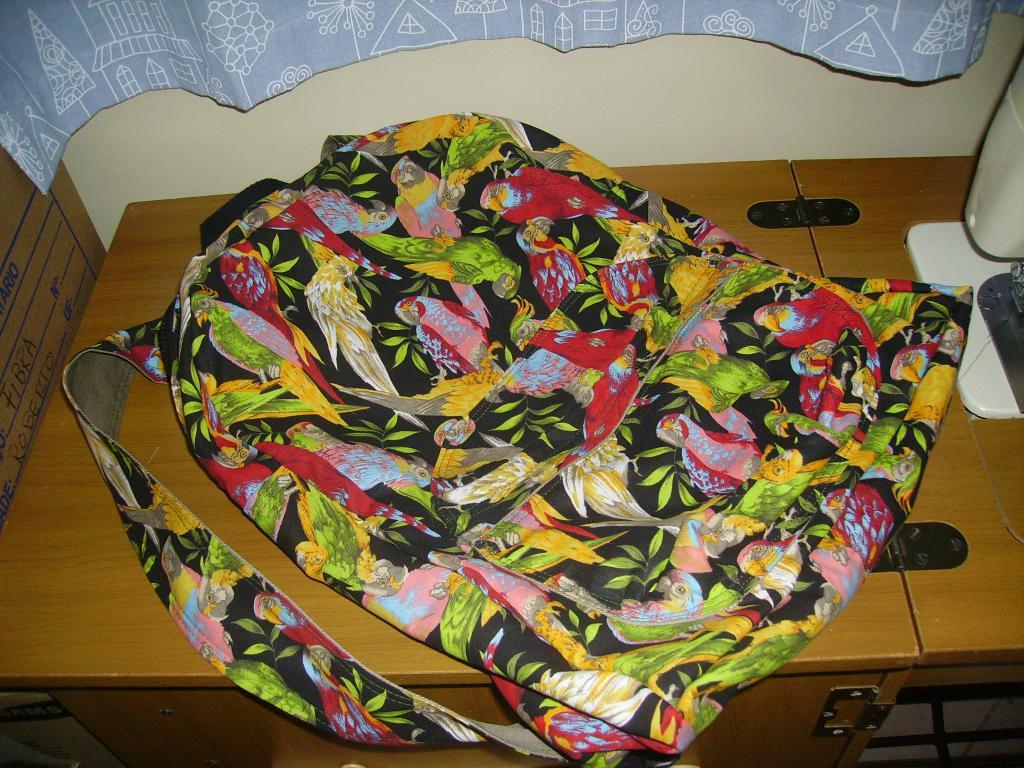What is on the table in the image? There is a bag on the table in the image. What can be seen on the bag? The bag has images of parrots and leaves on it. What is visible at the top of the image? There is a curtain at the top of the image. Where is the toothbrush located in the image? There is no toothbrush present in the image. What type of coat is hanging on the curtain in the image? There is no coat present in the image, and the curtain is not mentioned as having a coat hanging on it. 